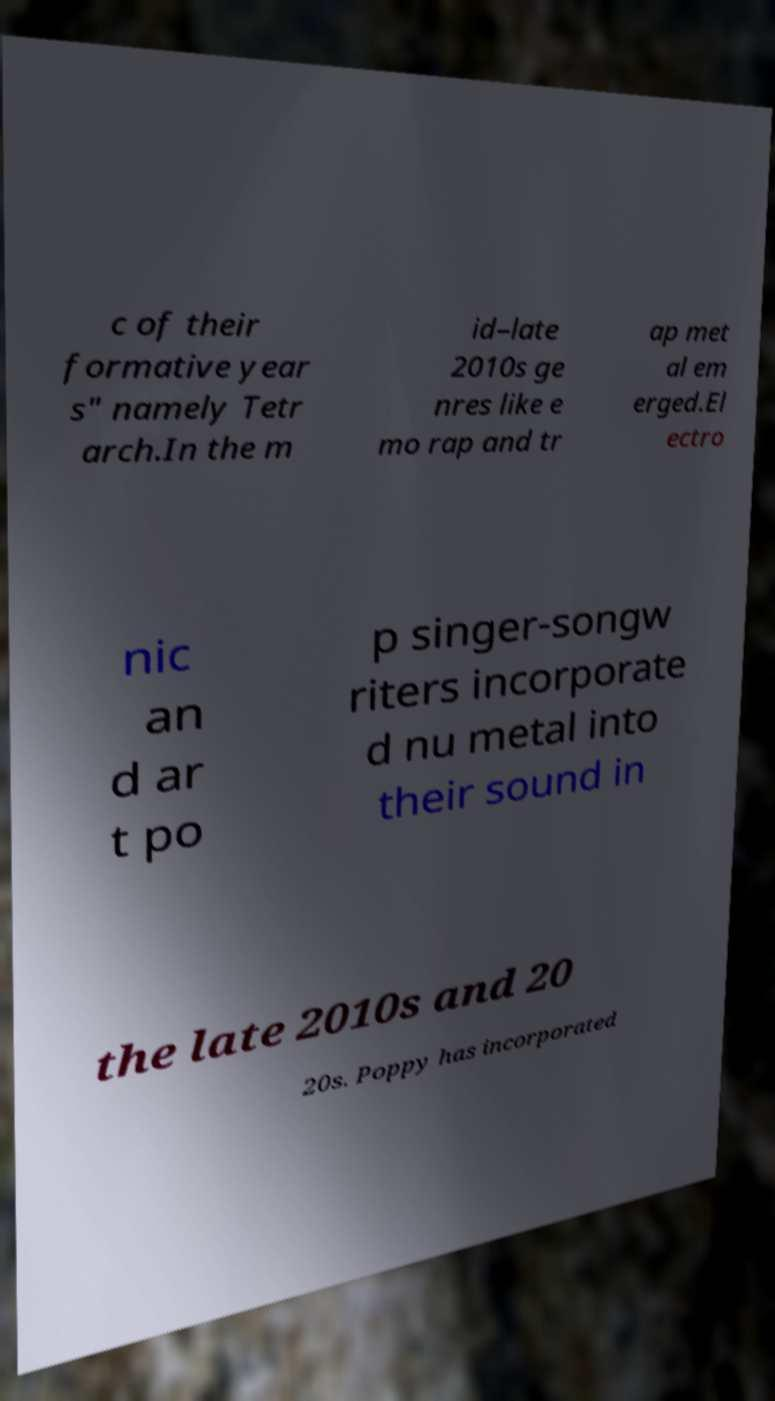What messages or text are displayed in this image? I need them in a readable, typed format. c of their formative year s" namely Tetr arch.In the m id–late 2010s ge nres like e mo rap and tr ap met al em erged.El ectro nic an d ar t po p singer-songw riters incorporate d nu metal into their sound in the late 2010s and 20 20s. Poppy has incorporated 